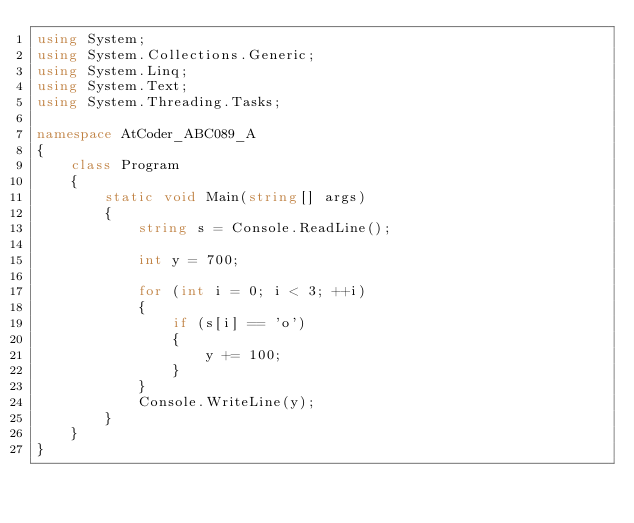Convert code to text. <code><loc_0><loc_0><loc_500><loc_500><_C#_>using System;
using System.Collections.Generic;
using System.Linq;
using System.Text;
using System.Threading.Tasks;

namespace AtCoder_ABC089_A
{
    class Program
    {
        static void Main(string[] args)
        {
            string s = Console.ReadLine();

            int y = 700;

            for (int i = 0; i < 3; ++i)
            {
                if (s[i] == 'o')
                {
                    y += 100;
                }
            }
            Console.WriteLine(y);
        }
    }
}
</code> 